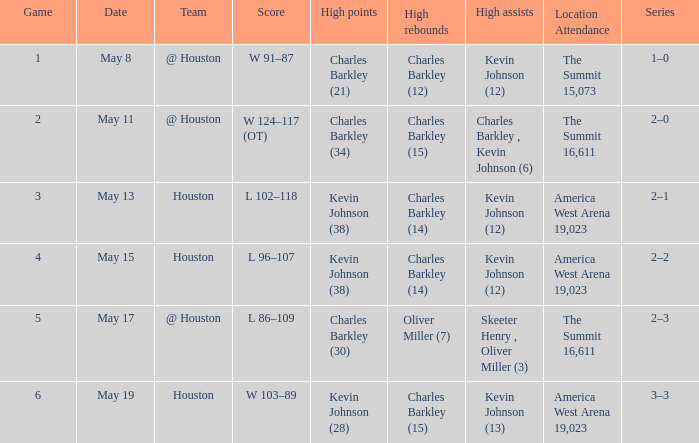In how many distinct games did oliver miller (7) achieve the highest rebounds? 1.0. 